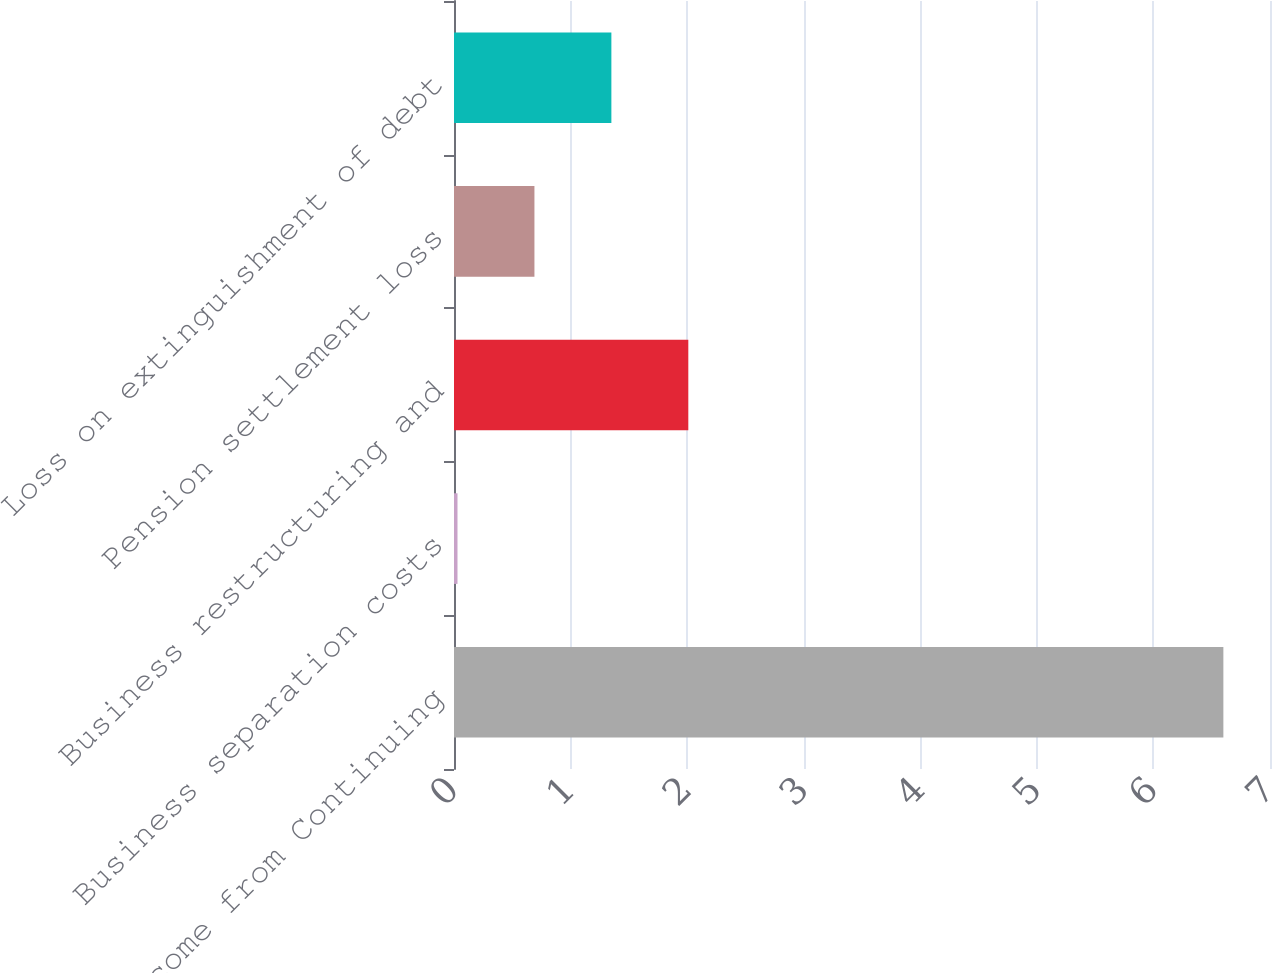Convert chart to OTSL. <chart><loc_0><loc_0><loc_500><loc_500><bar_chart><fcel>Income from Continuing<fcel>Business separation costs<fcel>Business restructuring and<fcel>Pension settlement loss<fcel>Loss on extinguishment of debt<nl><fcel>6.6<fcel>0.03<fcel>2.01<fcel>0.69<fcel>1.35<nl></chart> 